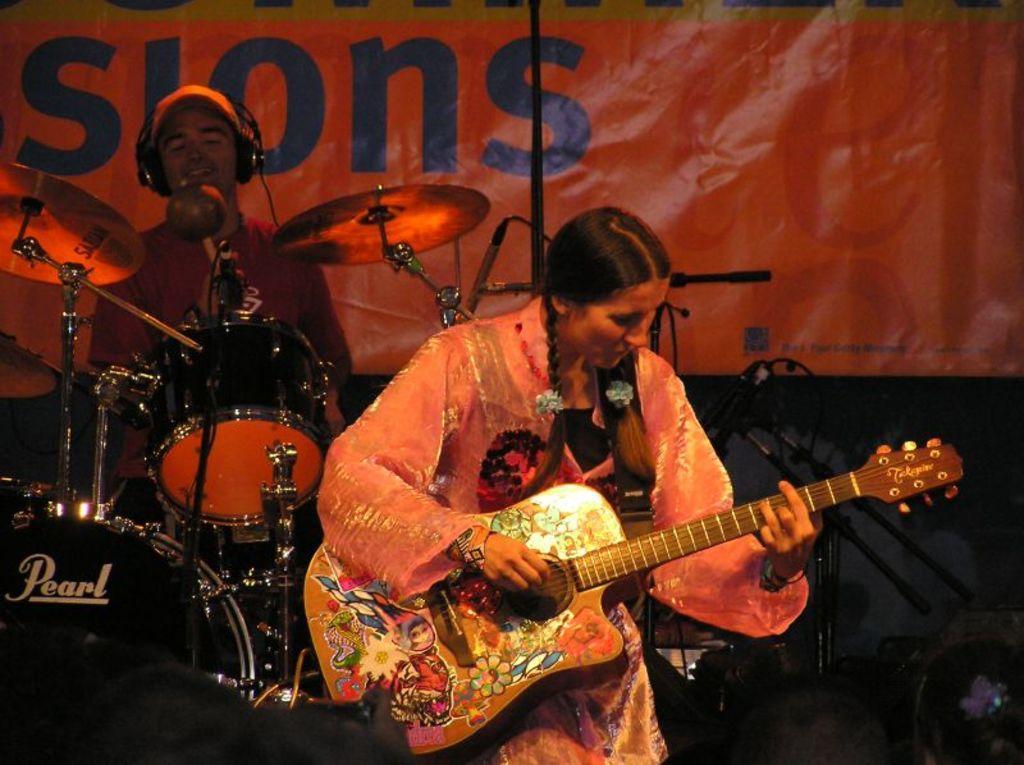Can you describe this image briefly? In the picture we can see a woman standing and holding a guitar, just behind her we can see a man playing a musical instruments with a cap and headset, in the background we can see a banner and named "LESIONS" on it. The woman who is standing is wearing a pink dress. 